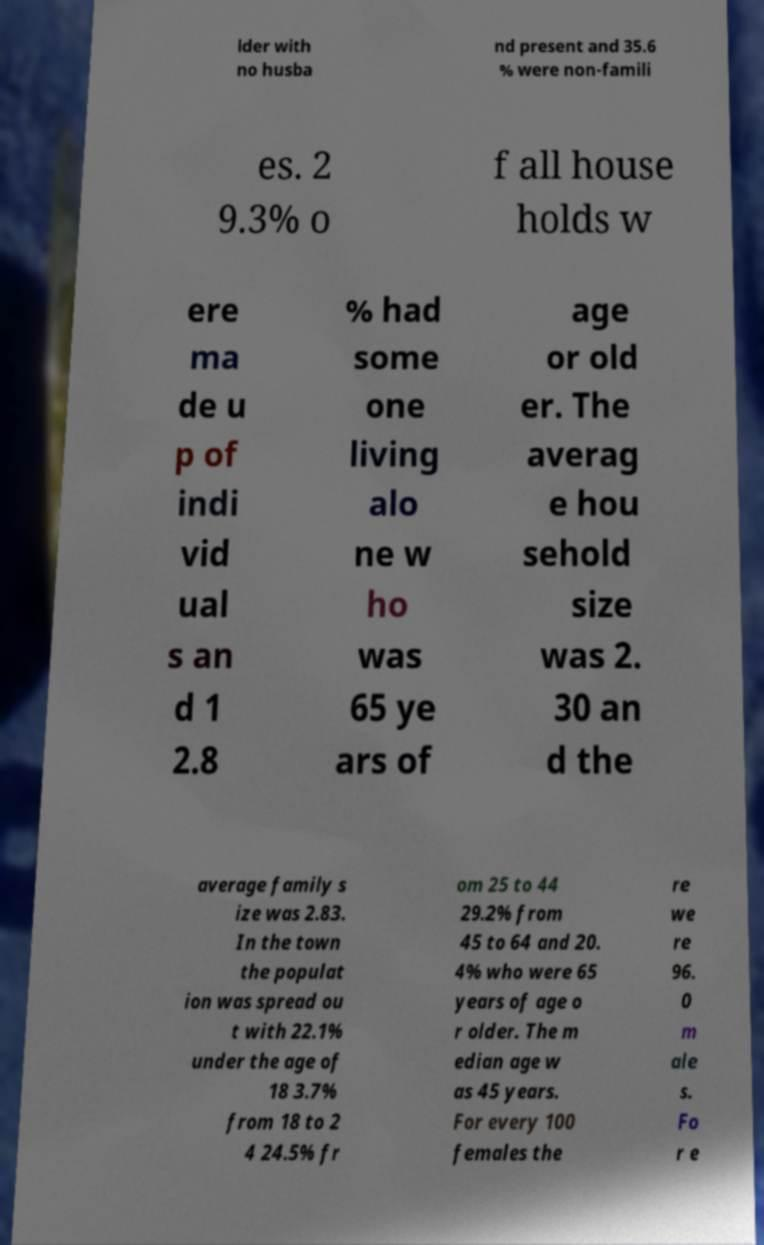Could you extract and type out the text from this image? lder with no husba nd present and 35.6 % were non-famili es. 2 9.3% o f all house holds w ere ma de u p of indi vid ual s an d 1 2.8 % had some one living alo ne w ho was 65 ye ars of age or old er. The averag e hou sehold size was 2. 30 an d the average family s ize was 2.83. In the town the populat ion was spread ou t with 22.1% under the age of 18 3.7% from 18 to 2 4 24.5% fr om 25 to 44 29.2% from 45 to 64 and 20. 4% who were 65 years of age o r older. The m edian age w as 45 years. For every 100 females the re we re 96. 0 m ale s. Fo r e 